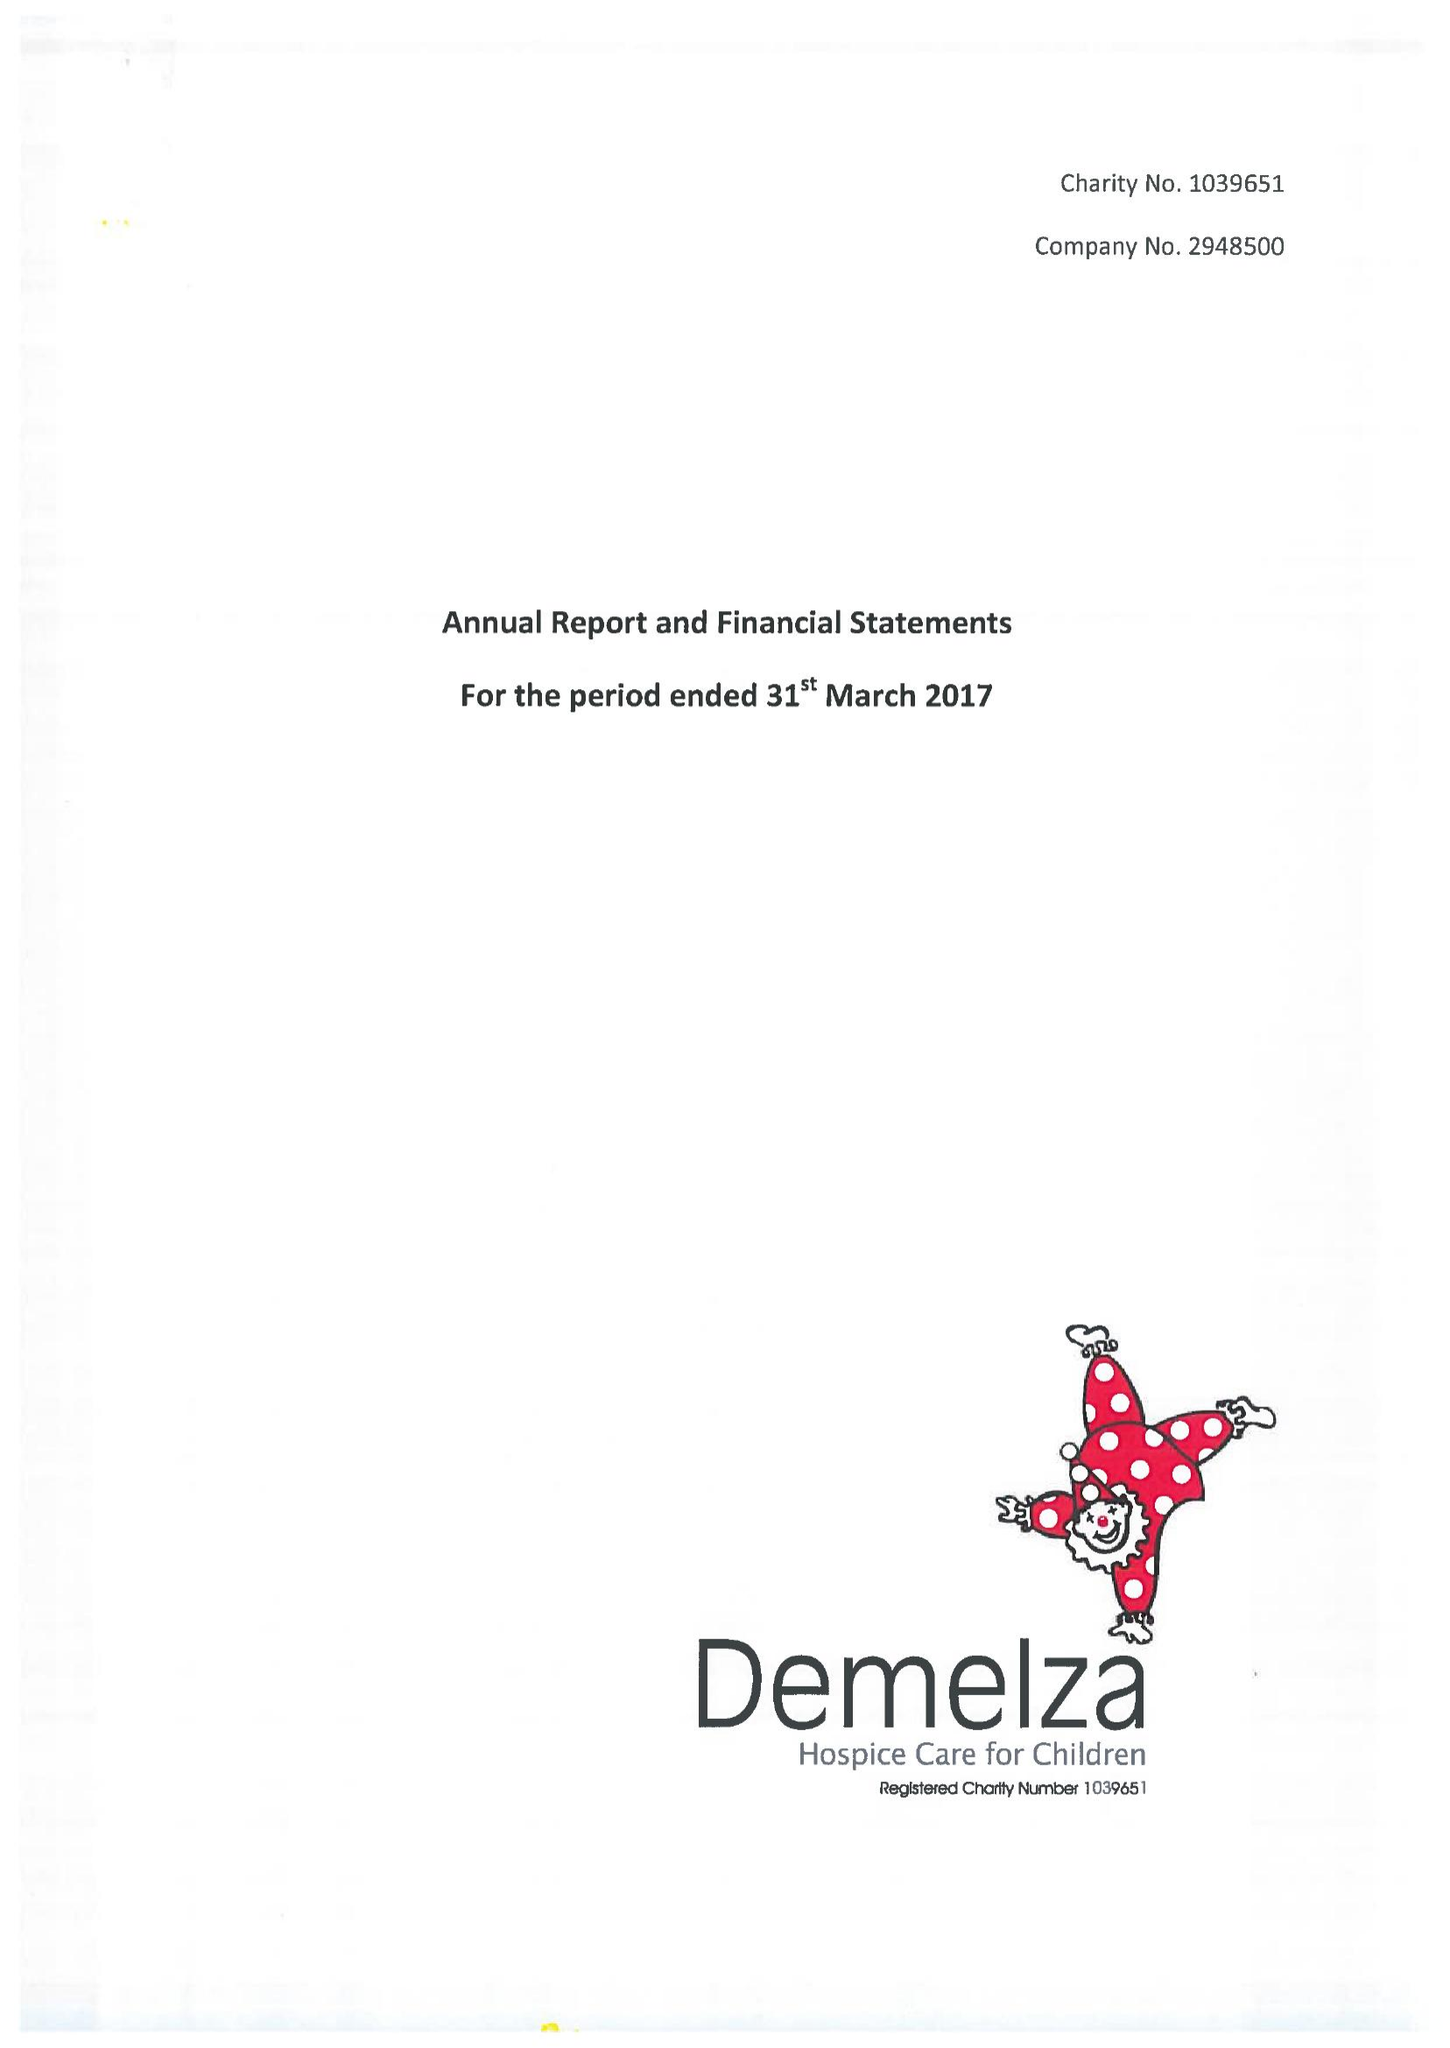What is the value for the address__post_town?
Answer the question using a single word or phrase. SITTINGBOURNE 